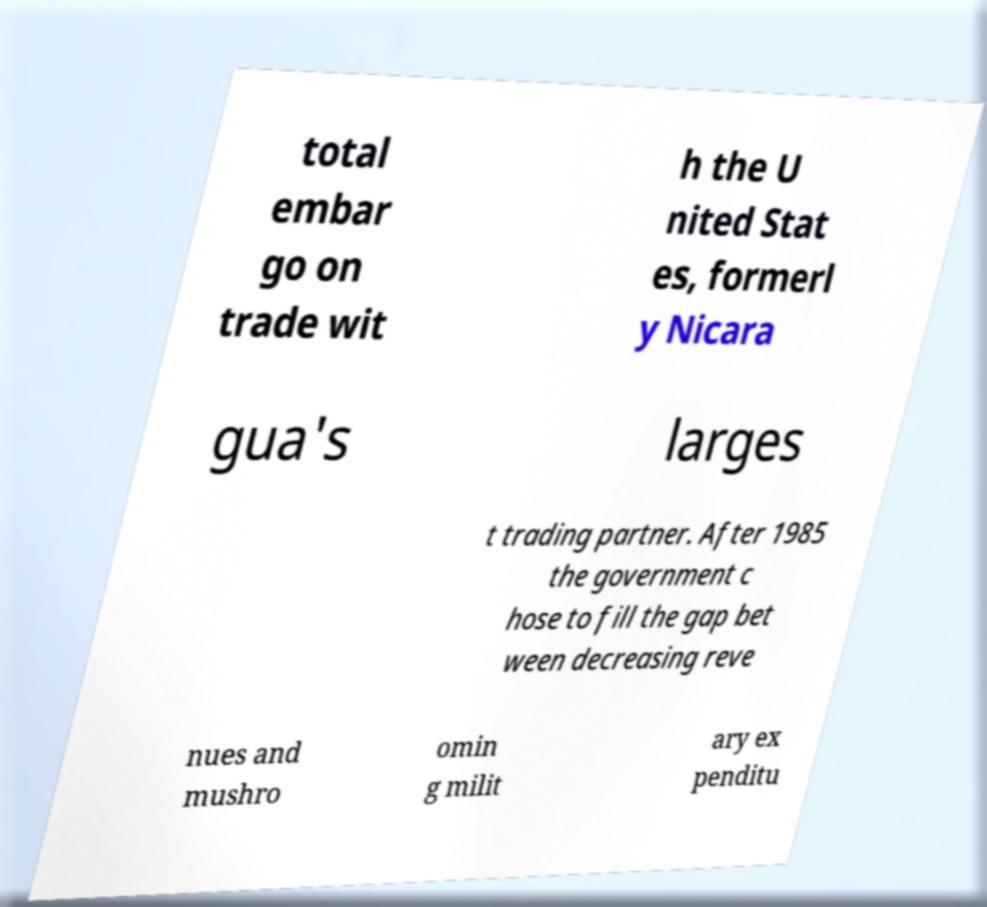Can you read and provide the text displayed in the image?This photo seems to have some interesting text. Can you extract and type it out for me? total embar go on trade wit h the U nited Stat es, formerl y Nicara gua's larges t trading partner. After 1985 the government c hose to fill the gap bet ween decreasing reve nues and mushro omin g milit ary ex penditu 